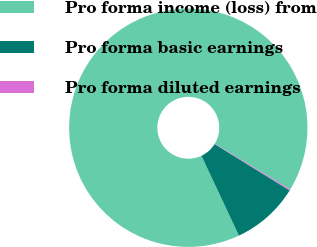Convert chart. <chart><loc_0><loc_0><loc_500><loc_500><pie_chart><fcel>Pro forma income (loss) from<fcel>Pro forma basic earnings<fcel>Pro forma diluted earnings<nl><fcel>90.64%<fcel>9.2%<fcel>0.15%<nl></chart> 